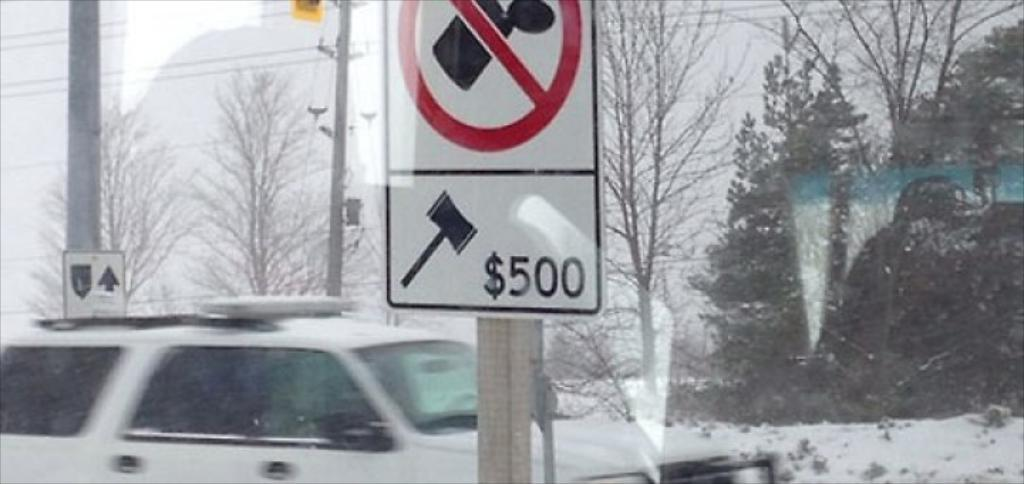What is on the wooden pole in the image? There is a sign board on a wooden pole in the image. What type of vehicle can be seen in the image? There is a car in the image. What are the poles in the image used for? The poles in the image are likely used for supporting wires. What can be seen connected to the poles in the image? There are wires in the image. What type of vegetation is present in the image? There is a group of trees in the image. What other objects can be seen in the image? There are boards in the image. What is the weather like in the image? There is snow visible in the image, and the sky is cloudy. What type of chalk is being used to draw on the car in the image? There is no chalk or drawing on the car in the image. What type of seed is being planted near the trees in the image? There is no seed planting activity depicted in the image. 